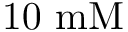<formula> <loc_0><loc_0><loc_500><loc_500>1 0 m M</formula> 